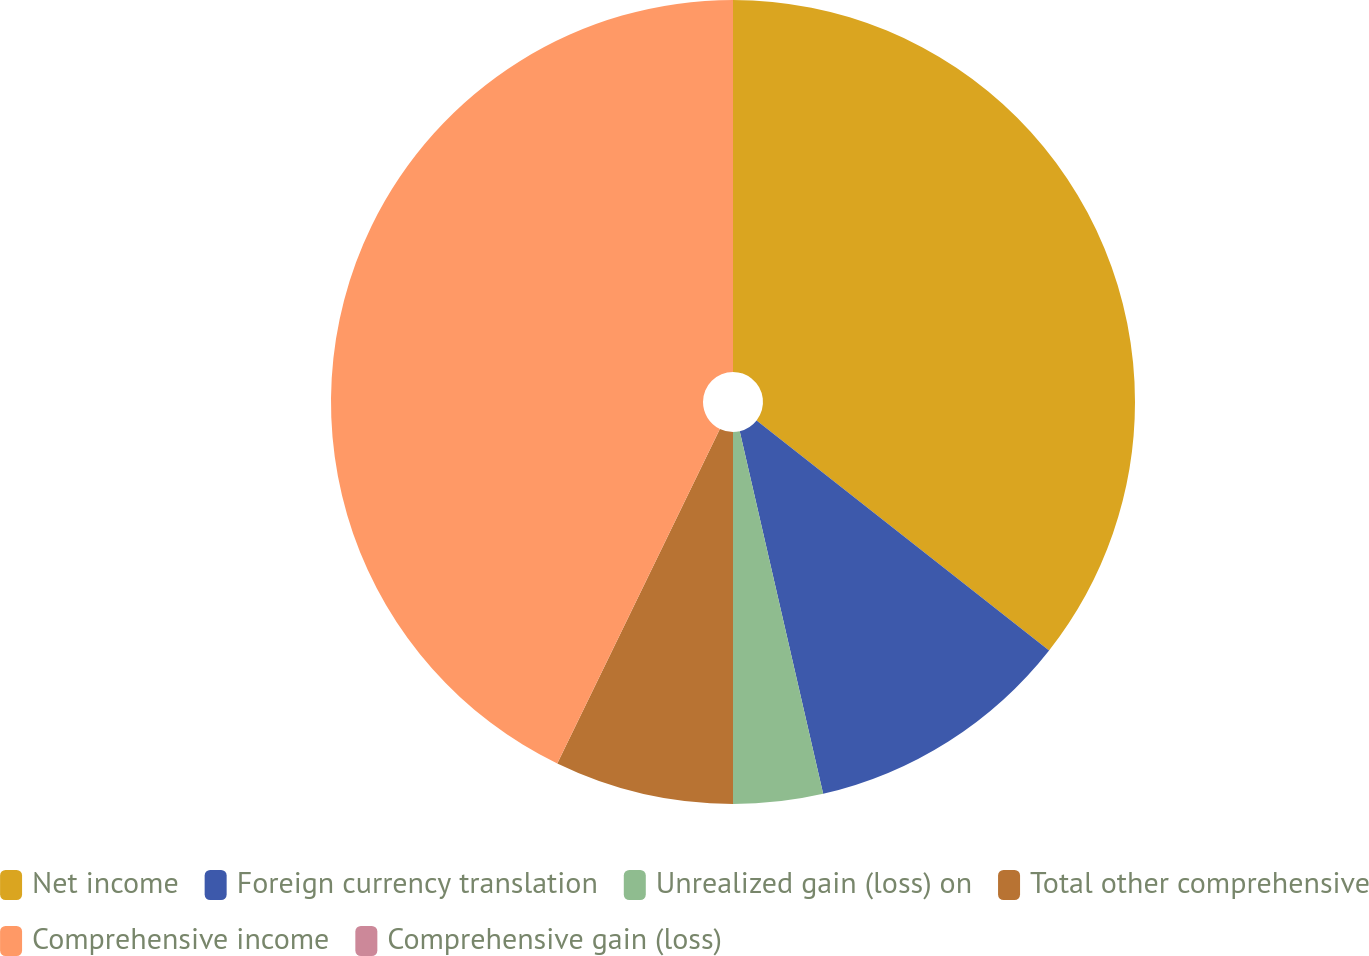<chart> <loc_0><loc_0><loc_500><loc_500><pie_chart><fcel>Net income<fcel>Foreign currency translation<fcel>Unrealized gain (loss) on<fcel>Total other comprehensive<fcel>Comprehensive income<fcel>Comprehensive gain (loss)<nl><fcel>35.6%<fcel>10.8%<fcel>3.6%<fcel>7.2%<fcel>42.8%<fcel>0.0%<nl></chart> 